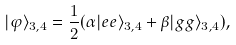Convert formula to latex. <formula><loc_0><loc_0><loc_500><loc_500>| \varphi \rangle _ { 3 , 4 } = \frac { 1 } { 2 } ( \alpha | e e \rangle _ { 3 , 4 } + \beta | g g \rangle _ { 3 , 4 } ) ,</formula> 